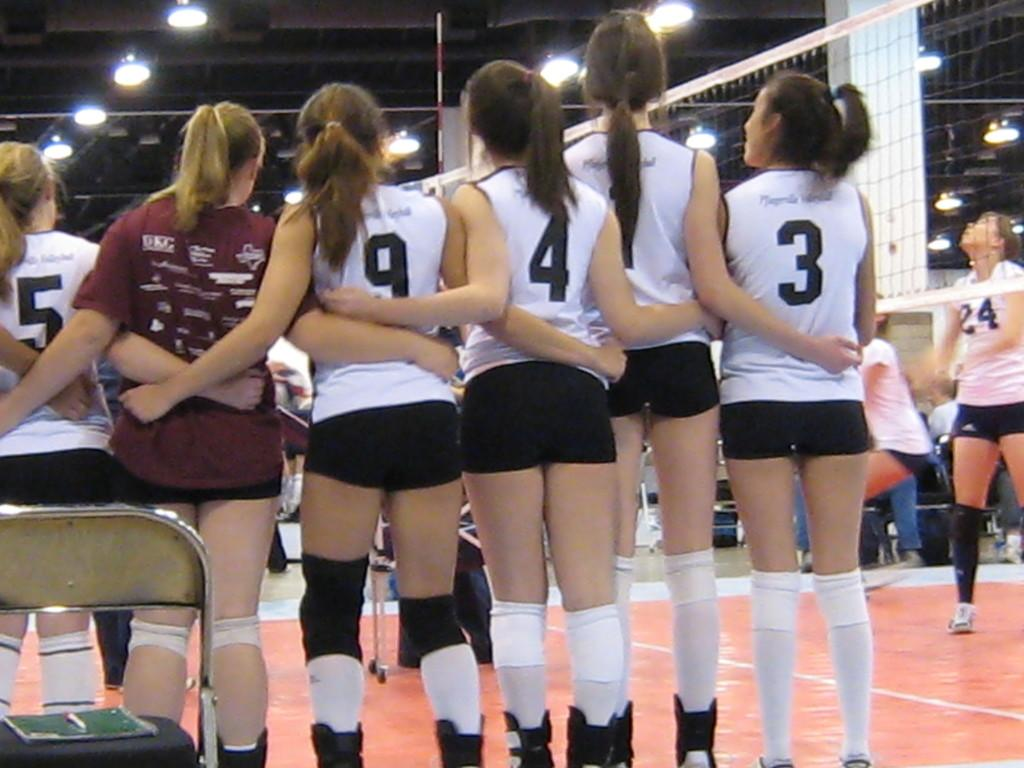<image>
Summarize the visual content of the image. Volleyball players wearing numbers 3, 1, 4 and 9 gather together. 